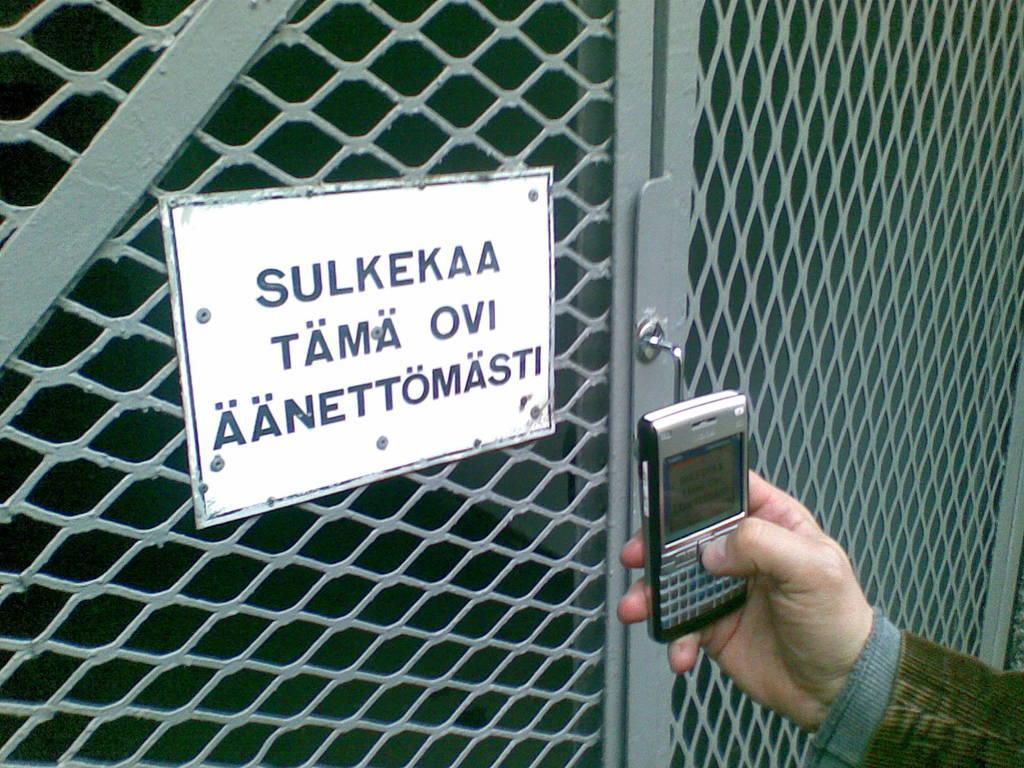Can you describe this image briefly? In this image, we can see a board on the door. There is a hand in the bottom right of the image holding a phone. 